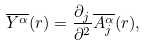<formula> <loc_0><loc_0><loc_500><loc_500>\overline { Y ^ { \alpha } } ( r ) = \frac { \partial _ { j } } { \partial ^ { 2 } } \overline { A _ { j } ^ { \alpha } } ( r ) ,</formula> 